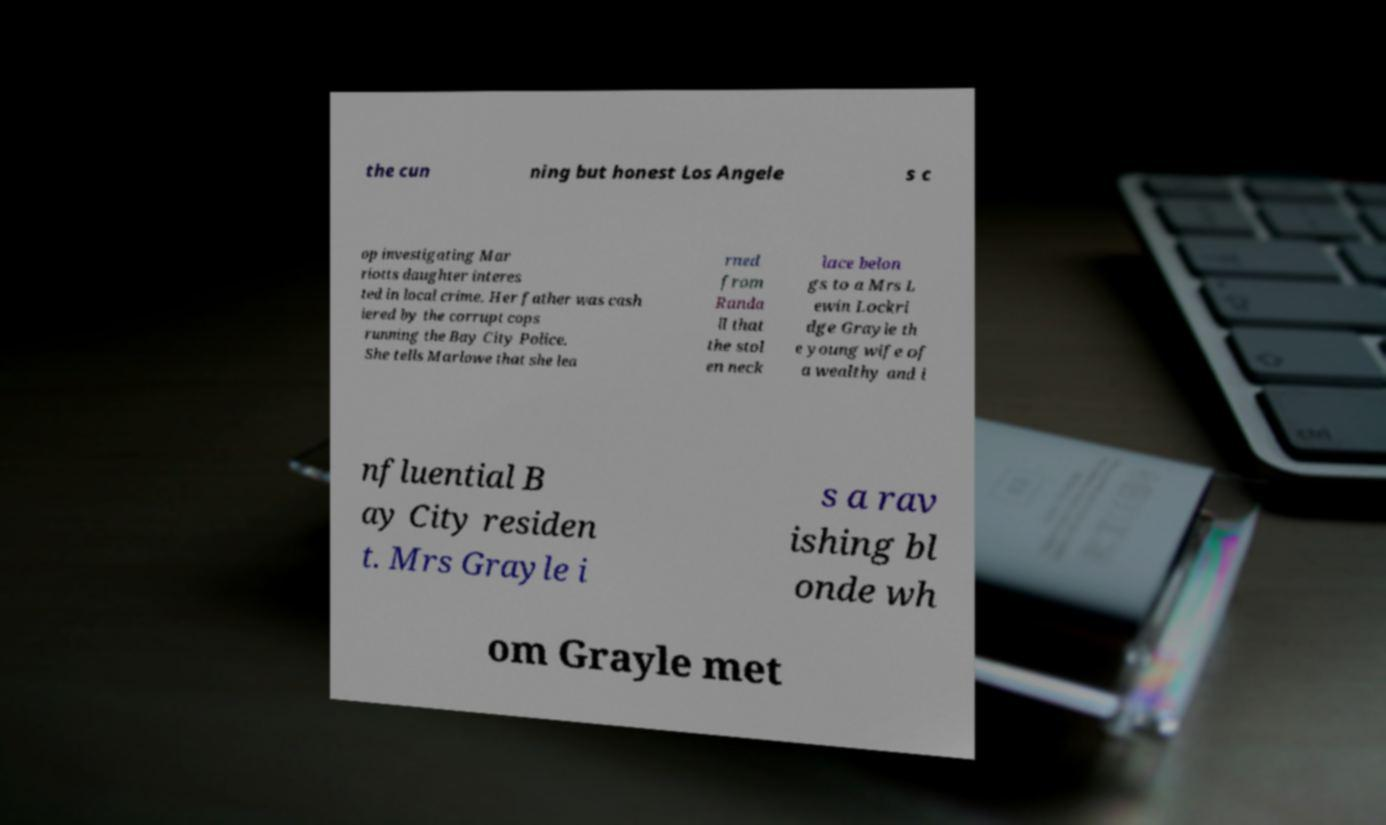There's text embedded in this image that I need extracted. Can you transcribe it verbatim? the cun ning but honest Los Angele s c op investigating Mar riotts daughter interes ted in local crime. Her father was cash iered by the corrupt cops running the Bay City Police. She tells Marlowe that she lea rned from Randa ll that the stol en neck lace belon gs to a Mrs L ewin Lockri dge Grayle th e young wife of a wealthy and i nfluential B ay City residen t. Mrs Grayle i s a rav ishing bl onde wh om Grayle met 